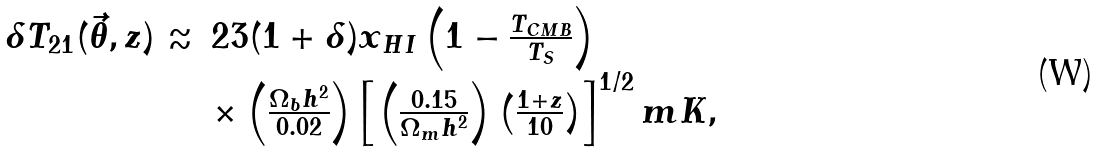<formula> <loc_0><loc_0><loc_500><loc_500>\begin{array} { r l } \delta T _ { 2 1 } ( \vec { \theta } , z ) \approx & 2 3 ( 1 + \delta ) x _ { H I } \left ( 1 - \frac { T _ { C M B } } { T _ { S } } \right ) \\ & \times \left ( \frac { \Omega _ { b } h ^ { 2 } } { 0 . 0 2 } \right ) \left [ \left ( \frac { 0 . 1 5 } { \Omega _ { m } h ^ { 2 } } \right ) \left ( \frac { 1 + z } { 1 0 } \right ) \right ] ^ { 1 / 2 } m K , \end{array}</formula> 